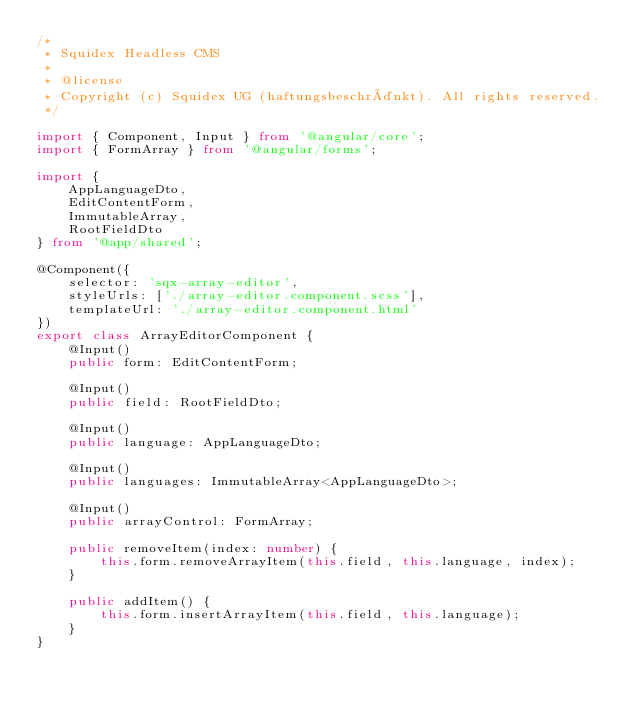<code> <loc_0><loc_0><loc_500><loc_500><_TypeScript_>/*
 * Squidex Headless CMS
 *
 * @license
 * Copyright (c) Squidex UG (haftungsbeschränkt). All rights reserved.
 */

import { Component, Input } from '@angular/core';
import { FormArray } from '@angular/forms';

import {
    AppLanguageDto,
    EditContentForm,
    ImmutableArray,
    RootFieldDto
} from '@app/shared';

@Component({
    selector: 'sqx-array-editor',
    styleUrls: ['./array-editor.component.scss'],
    templateUrl: './array-editor.component.html'
})
export class ArrayEditorComponent {
    @Input()
    public form: EditContentForm;

    @Input()
    public field: RootFieldDto;

    @Input()
    public language: AppLanguageDto;

    @Input()
    public languages: ImmutableArray<AppLanguageDto>;

    @Input()
    public arrayControl: FormArray;

    public removeItem(index: number) {
        this.form.removeArrayItem(this.field, this.language, index);
    }

    public addItem() {
        this.form.insertArrayItem(this.field, this.language);
    }
}</code> 